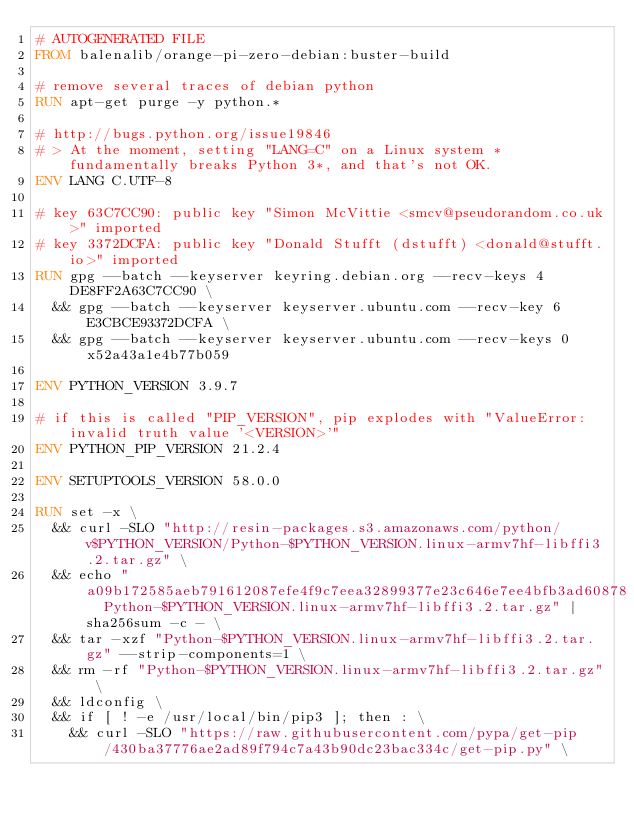<code> <loc_0><loc_0><loc_500><loc_500><_Dockerfile_># AUTOGENERATED FILE
FROM balenalib/orange-pi-zero-debian:buster-build

# remove several traces of debian python
RUN apt-get purge -y python.*

# http://bugs.python.org/issue19846
# > At the moment, setting "LANG=C" on a Linux system *fundamentally breaks Python 3*, and that's not OK.
ENV LANG C.UTF-8

# key 63C7CC90: public key "Simon McVittie <smcv@pseudorandom.co.uk>" imported
# key 3372DCFA: public key "Donald Stufft (dstufft) <donald@stufft.io>" imported
RUN gpg --batch --keyserver keyring.debian.org --recv-keys 4DE8FF2A63C7CC90 \
	&& gpg --batch --keyserver keyserver.ubuntu.com --recv-key 6E3CBCE93372DCFA \
	&& gpg --batch --keyserver keyserver.ubuntu.com --recv-keys 0x52a43a1e4b77b059

ENV PYTHON_VERSION 3.9.7

# if this is called "PIP_VERSION", pip explodes with "ValueError: invalid truth value '<VERSION>'"
ENV PYTHON_PIP_VERSION 21.2.4

ENV SETUPTOOLS_VERSION 58.0.0

RUN set -x \
	&& curl -SLO "http://resin-packages.s3.amazonaws.com/python/v$PYTHON_VERSION/Python-$PYTHON_VERSION.linux-armv7hf-libffi3.2.tar.gz" \
	&& echo "a09b172585aeb791612087efe4f9c7eea32899377e23c646e7ee4bfb3ad60878  Python-$PYTHON_VERSION.linux-armv7hf-libffi3.2.tar.gz" | sha256sum -c - \
	&& tar -xzf "Python-$PYTHON_VERSION.linux-armv7hf-libffi3.2.tar.gz" --strip-components=1 \
	&& rm -rf "Python-$PYTHON_VERSION.linux-armv7hf-libffi3.2.tar.gz" \
	&& ldconfig \
	&& if [ ! -e /usr/local/bin/pip3 ]; then : \
		&& curl -SLO "https://raw.githubusercontent.com/pypa/get-pip/430ba37776ae2ad89f794c7a43b90dc23bac334c/get-pip.py" \</code> 